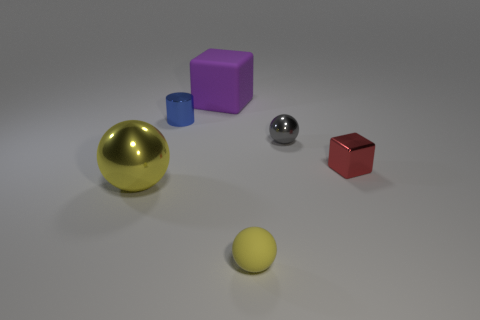Add 2 yellow metal things. How many objects exist? 8 Subtract all blocks. How many objects are left? 4 Add 1 red things. How many red things are left? 2 Add 5 red objects. How many red objects exist? 6 Subtract 0 purple spheres. How many objects are left? 6 Subtract all red matte balls. Subtract all large metal things. How many objects are left? 5 